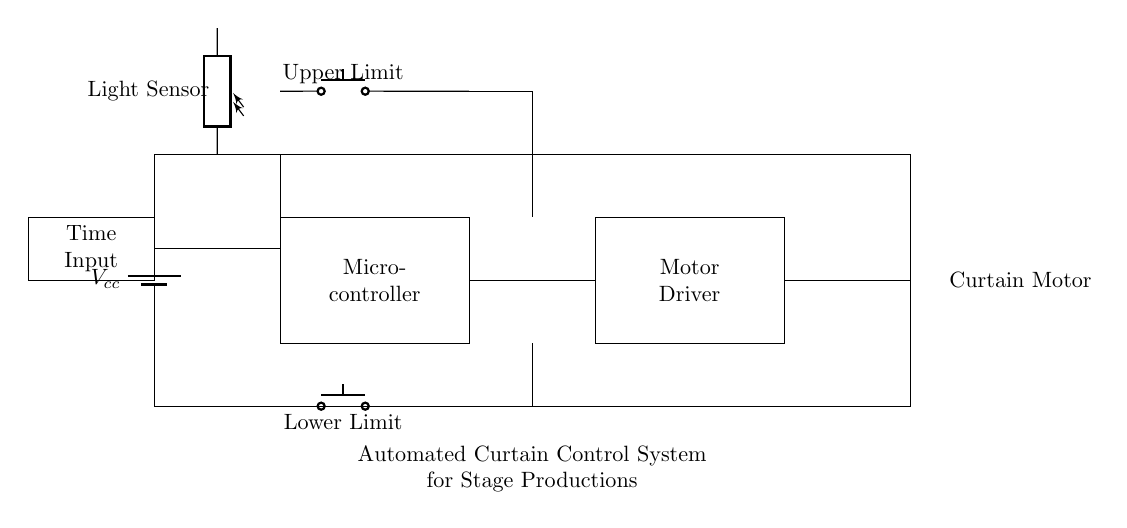What is the main component that controls the curtain movement? The main component responsible for driving the curtain movement is the curtain motor, which converts electrical energy into mechanical motion to open or close the curtains.
Answer: Curtain Motor What powers the entire circuit? The circuit is powered by a battery, indicated as Vcc in the diagram, which provides the necessary electrical energy for the operation of the components.
Answer: Vcc Which component detects light levels? The light sensor is the component used to detect ambient light levels, providing input to automate curtain adjustments based on lighting conditions in the performance.
Answer: Light Sensor What is the role of the microcontroller in this circuit? The microcontroller processes inputs, such as time settings and sensor readings, and controls the motor driver to operate the curtain motor precisely according to the programmed timings.
Answer: Microcontroller How many limit switches are present in the circuit? There are two limit switches included in the circuit: one for the upper limit and one for the lower limit, ensuring that the motor stops when the curtains are fully opened or closed.
Answer: Two What is the function of the motor driver in this setup? The motor driver receives signals from the microcontroller and amplifies them to provide sufficient current to the curtain motor, allowing precise control of its movement direction and speed.
Answer: Amplification of signals What type of switches are employed for the limit functions? The switches used as limit switches in this circuit are push buttons, which are designed to open or close the circuit when pressed, signaling the microcontroller to stop the motor.
Answer: Push Buttons 